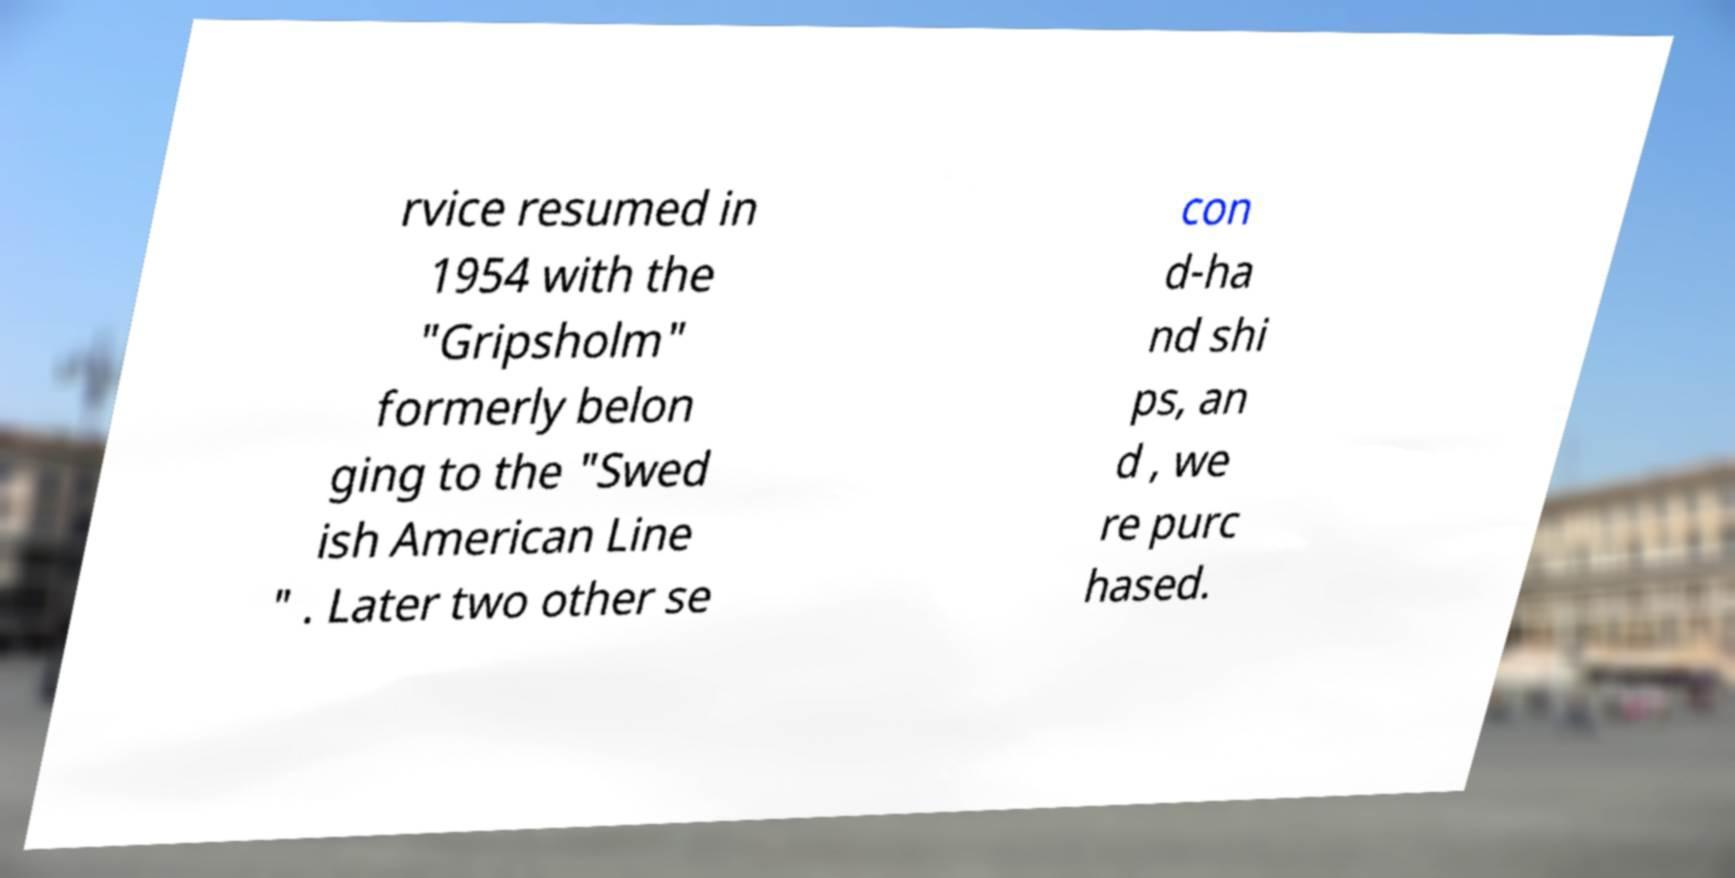For documentation purposes, I need the text within this image transcribed. Could you provide that? rvice resumed in 1954 with the "Gripsholm" formerly belon ging to the "Swed ish American Line " . Later two other se con d-ha nd shi ps, an d , we re purc hased. 